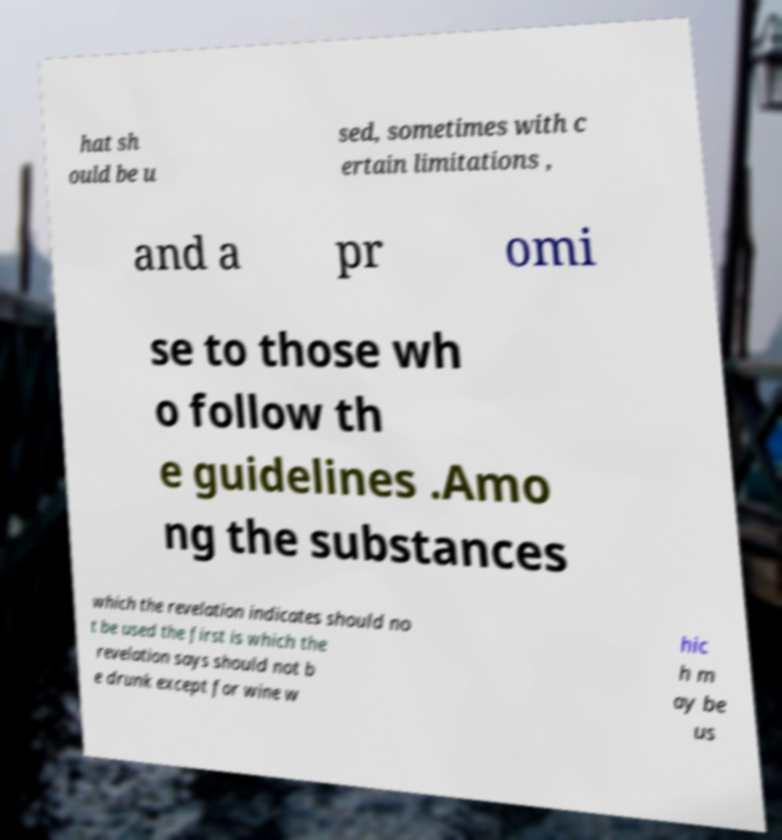Could you assist in decoding the text presented in this image and type it out clearly? hat sh ould be u sed, sometimes with c ertain limitations , and a pr omi se to those wh o follow th e guidelines .Amo ng the substances which the revelation indicates should no t be used the first is which the revelation says should not b e drunk except for wine w hic h m ay be us 